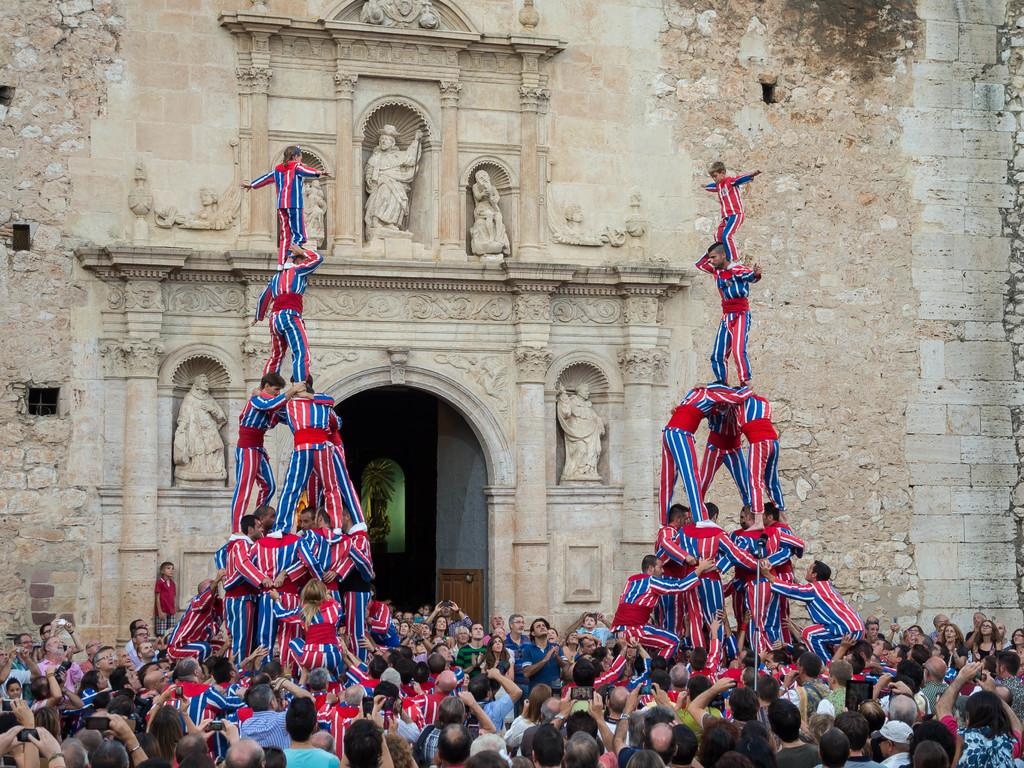What activity are the persons in the foreground of the image engaged in? The persons in the foreground of the image are performing a pyramid. What can be seen around the persons performing the pyramid? There is a crowd around the persons performing the pyramid. What is visible in the background of the image? There is a wall with sculptures in the background of the image. What decision did the person in the pocket make in the image? There is no person in a pocket present in the image, and therefore no such decision can be made. 